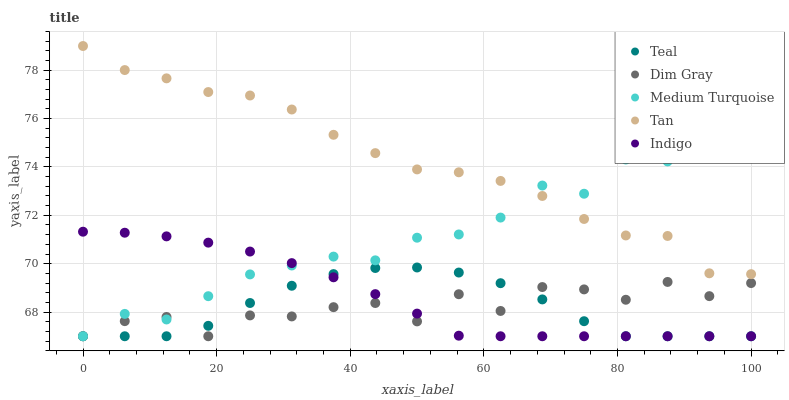Does Teal have the minimum area under the curve?
Answer yes or no. Yes. Does Tan have the maximum area under the curve?
Answer yes or no. Yes. Does Dim Gray have the minimum area under the curve?
Answer yes or no. No. Does Dim Gray have the maximum area under the curve?
Answer yes or no. No. Is Indigo the smoothest?
Answer yes or no. Yes. Is Dim Gray the roughest?
Answer yes or no. Yes. Is Dim Gray the smoothest?
Answer yes or no. No. Is Indigo the roughest?
Answer yes or no. No. Does Dim Gray have the lowest value?
Answer yes or no. Yes. Does Tan have the highest value?
Answer yes or no. Yes. Does Indigo have the highest value?
Answer yes or no. No. Is Teal less than Tan?
Answer yes or no. Yes. Is Tan greater than Teal?
Answer yes or no. Yes. Does Medium Turquoise intersect Teal?
Answer yes or no. Yes. Is Medium Turquoise less than Teal?
Answer yes or no. No. Is Medium Turquoise greater than Teal?
Answer yes or no. No. Does Teal intersect Tan?
Answer yes or no. No. 